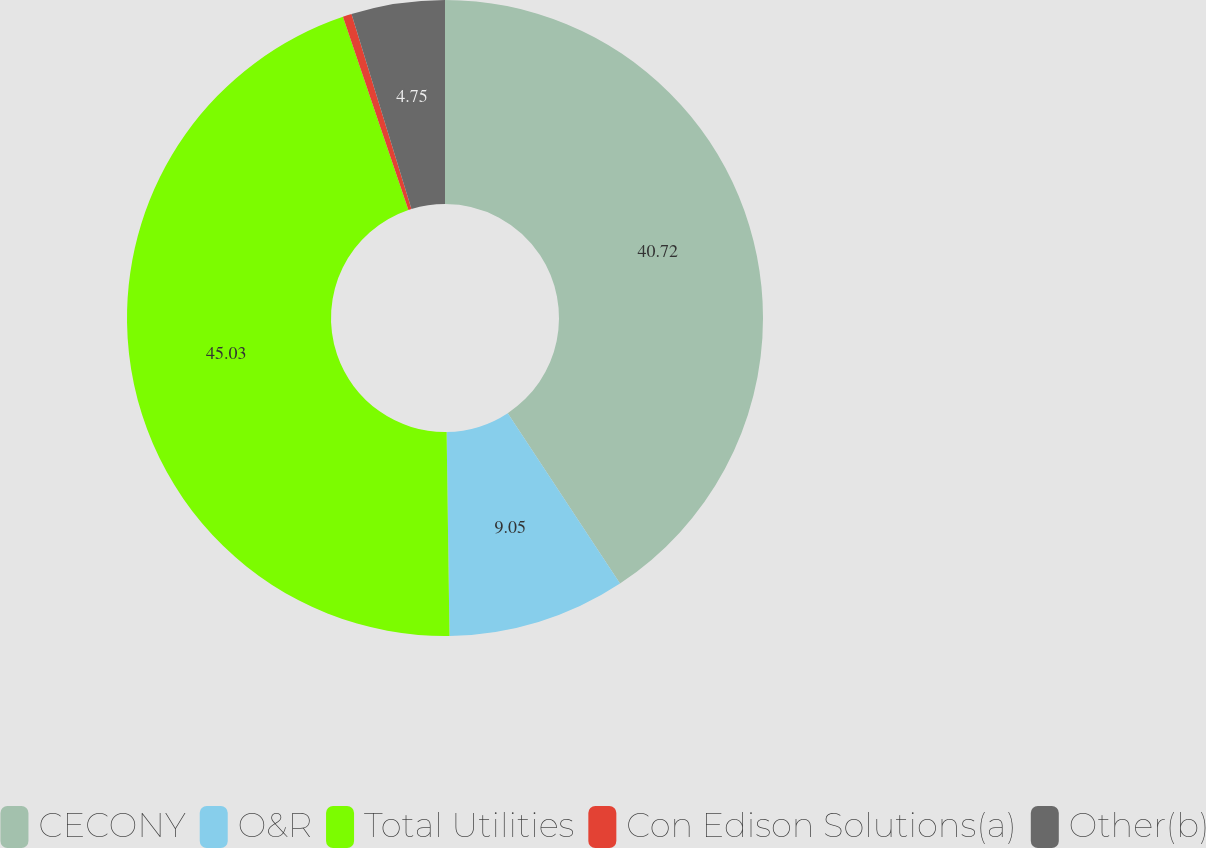Convert chart to OTSL. <chart><loc_0><loc_0><loc_500><loc_500><pie_chart><fcel>CECONY<fcel>O&R<fcel>Total Utilities<fcel>Con Edison Solutions(a)<fcel>Other(b)<nl><fcel>40.72%<fcel>9.05%<fcel>45.02%<fcel>0.45%<fcel>4.75%<nl></chart> 